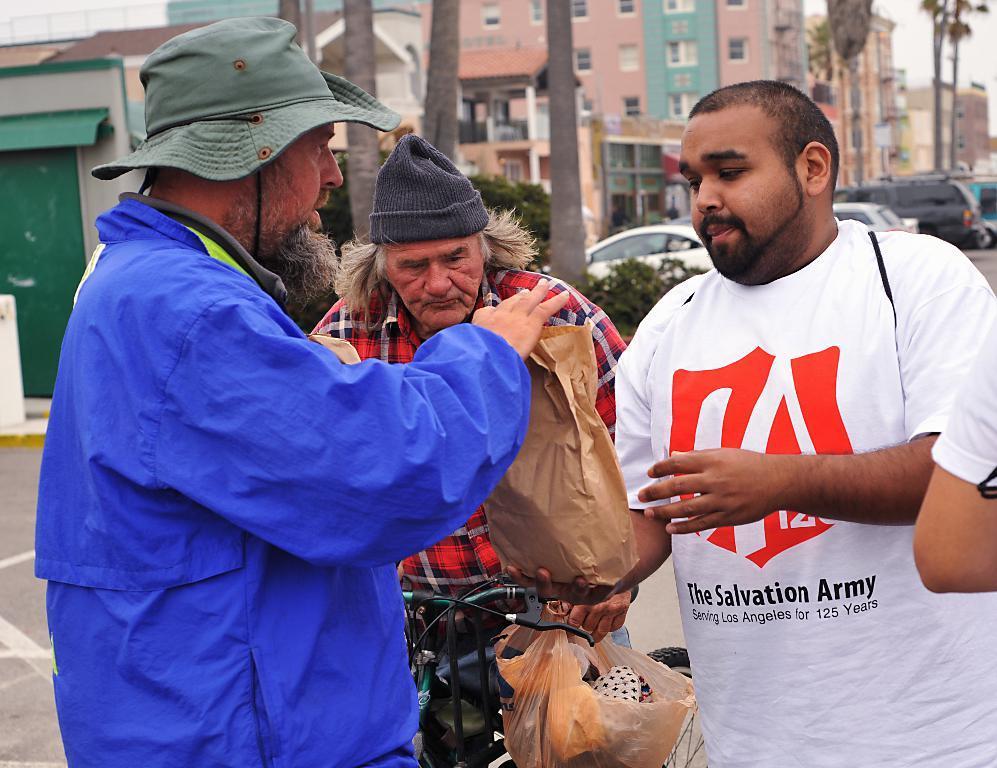Please provide a concise description of this image. In this image in the foreground there are two persons holding a paper cover, in between them there is a person who is sitting on the bi-cycle, there is a cover attached to the handle, on the right side there is a person's hand, in the middle there are vehicles, plants, buildings, trunk of tree visible. 